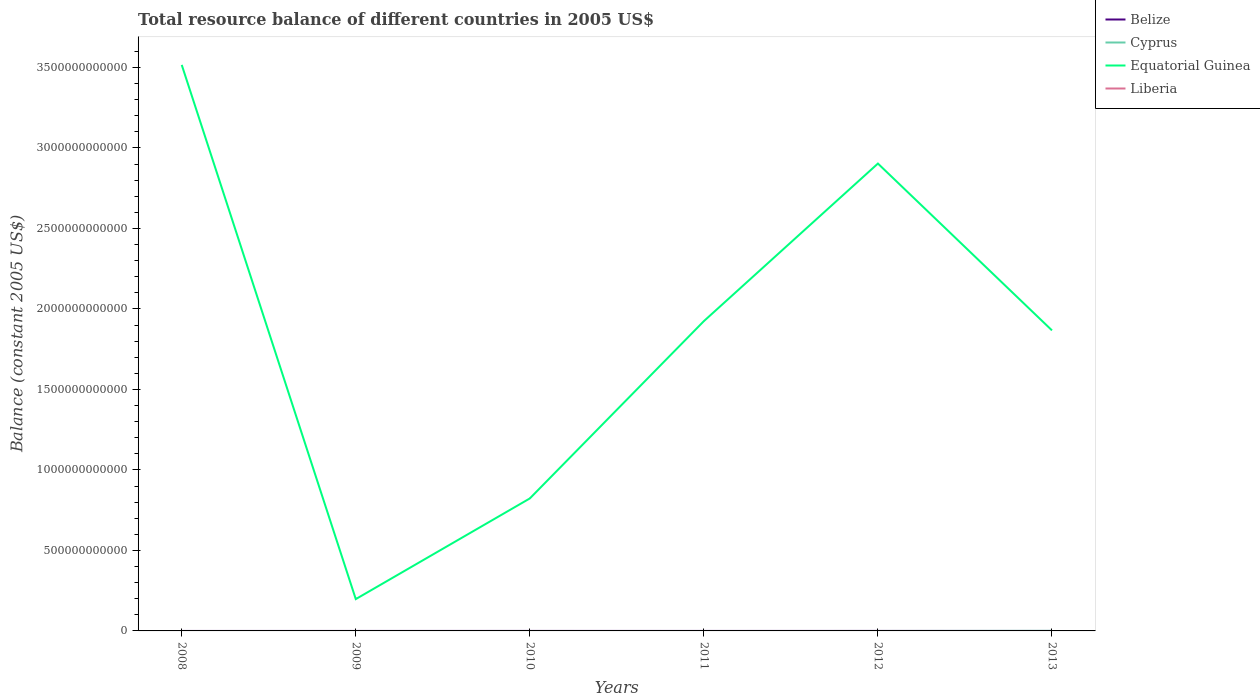How many different coloured lines are there?
Your answer should be very brief. 3. What is the total total resource balance in Equatorial Guinea in the graph?
Your answer should be compact. 1.04e+12. What is the difference between the highest and the second highest total resource balance in Belize?
Give a very brief answer. 2.07e+07. What is the difference between the highest and the lowest total resource balance in Belize?
Keep it short and to the point. 1. Is the total resource balance in Equatorial Guinea strictly greater than the total resource balance in Belize over the years?
Your response must be concise. No. How many years are there in the graph?
Offer a very short reply. 6. What is the difference between two consecutive major ticks on the Y-axis?
Offer a terse response. 5.00e+11. Does the graph contain grids?
Offer a very short reply. No. Where does the legend appear in the graph?
Offer a very short reply. Top right. How are the legend labels stacked?
Make the answer very short. Vertical. What is the title of the graph?
Make the answer very short. Total resource balance of different countries in 2005 US$. What is the label or title of the X-axis?
Your answer should be very brief. Years. What is the label or title of the Y-axis?
Provide a short and direct response. Balance (constant 2005 US$). What is the Balance (constant 2005 US$) in Belize in 2008?
Give a very brief answer. 0. What is the Balance (constant 2005 US$) of Equatorial Guinea in 2008?
Give a very brief answer. 3.52e+12. What is the Balance (constant 2005 US$) in Liberia in 2008?
Your answer should be compact. 0. What is the Balance (constant 2005 US$) in Cyprus in 2009?
Provide a succinct answer. 0. What is the Balance (constant 2005 US$) of Equatorial Guinea in 2009?
Give a very brief answer. 1.98e+11. What is the Balance (constant 2005 US$) of Liberia in 2009?
Your answer should be very brief. 0. What is the Balance (constant 2005 US$) of Belize in 2010?
Offer a very short reply. 2.07e+07. What is the Balance (constant 2005 US$) in Equatorial Guinea in 2010?
Your response must be concise. 8.23e+11. What is the Balance (constant 2005 US$) of Equatorial Guinea in 2011?
Ensure brevity in your answer.  1.92e+12. What is the Balance (constant 2005 US$) in Cyprus in 2012?
Provide a short and direct response. 0. What is the Balance (constant 2005 US$) of Equatorial Guinea in 2012?
Offer a terse response. 2.90e+12. What is the Balance (constant 2005 US$) of Cyprus in 2013?
Offer a very short reply. 4.50e+08. What is the Balance (constant 2005 US$) of Equatorial Guinea in 2013?
Your answer should be compact. 1.87e+12. What is the Balance (constant 2005 US$) of Liberia in 2013?
Your response must be concise. 0. Across all years, what is the maximum Balance (constant 2005 US$) of Belize?
Your response must be concise. 2.07e+07. Across all years, what is the maximum Balance (constant 2005 US$) of Cyprus?
Your answer should be compact. 4.50e+08. Across all years, what is the maximum Balance (constant 2005 US$) of Equatorial Guinea?
Provide a short and direct response. 3.52e+12. Across all years, what is the minimum Balance (constant 2005 US$) of Equatorial Guinea?
Offer a terse response. 1.98e+11. What is the total Balance (constant 2005 US$) of Belize in the graph?
Offer a very short reply. 2.07e+07. What is the total Balance (constant 2005 US$) in Cyprus in the graph?
Your response must be concise. 4.50e+08. What is the total Balance (constant 2005 US$) of Equatorial Guinea in the graph?
Give a very brief answer. 1.12e+13. What is the total Balance (constant 2005 US$) of Liberia in the graph?
Keep it short and to the point. 0. What is the difference between the Balance (constant 2005 US$) in Equatorial Guinea in 2008 and that in 2009?
Provide a short and direct response. 3.32e+12. What is the difference between the Balance (constant 2005 US$) in Equatorial Guinea in 2008 and that in 2010?
Your response must be concise. 2.69e+12. What is the difference between the Balance (constant 2005 US$) of Equatorial Guinea in 2008 and that in 2011?
Provide a short and direct response. 1.59e+12. What is the difference between the Balance (constant 2005 US$) in Equatorial Guinea in 2008 and that in 2012?
Make the answer very short. 6.13e+11. What is the difference between the Balance (constant 2005 US$) in Equatorial Guinea in 2008 and that in 2013?
Your answer should be very brief. 1.65e+12. What is the difference between the Balance (constant 2005 US$) in Equatorial Guinea in 2009 and that in 2010?
Offer a very short reply. -6.25e+11. What is the difference between the Balance (constant 2005 US$) of Equatorial Guinea in 2009 and that in 2011?
Keep it short and to the point. -1.73e+12. What is the difference between the Balance (constant 2005 US$) of Equatorial Guinea in 2009 and that in 2012?
Make the answer very short. -2.71e+12. What is the difference between the Balance (constant 2005 US$) in Equatorial Guinea in 2009 and that in 2013?
Provide a short and direct response. -1.67e+12. What is the difference between the Balance (constant 2005 US$) of Equatorial Guinea in 2010 and that in 2011?
Make the answer very short. -1.10e+12. What is the difference between the Balance (constant 2005 US$) of Equatorial Guinea in 2010 and that in 2012?
Your response must be concise. -2.08e+12. What is the difference between the Balance (constant 2005 US$) of Equatorial Guinea in 2010 and that in 2013?
Keep it short and to the point. -1.04e+12. What is the difference between the Balance (constant 2005 US$) of Equatorial Guinea in 2011 and that in 2012?
Give a very brief answer. -9.79e+11. What is the difference between the Balance (constant 2005 US$) in Equatorial Guinea in 2011 and that in 2013?
Provide a short and direct response. 5.76e+1. What is the difference between the Balance (constant 2005 US$) in Equatorial Guinea in 2012 and that in 2013?
Your response must be concise. 1.04e+12. What is the difference between the Balance (constant 2005 US$) in Belize in 2010 and the Balance (constant 2005 US$) in Equatorial Guinea in 2011?
Offer a terse response. -1.92e+12. What is the difference between the Balance (constant 2005 US$) in Belize in 2010 and the Balance (constant 2005 US$) in Equatorial Guinea in 2012?
Provide a short and direct response. -2.90e+12. What is the difference between the Balance (constant 2005 US$) of Belize in 2010 and the Balance (constant 2005 US$) of Cyprus in 2013?
Ensure brevity in your answer.  -4.30e+08. What is the difference between the Balance (constant 2005 US$) in Belize in 2010 and the Balance (constant 2005 US$) in Equatorial Guinea in 2013?
Give a very brief answer. -1.87e+12. What is the average Balance (constant 2005 US$) of Belize per year?
Provide a succinct answer. 3.45e+06. What is the average Balance (constant 2005 US$) in Cyprus per year?
Your response must be concise. 7.50e+07. What is the average Balance (constant 2005 US$) of Equatorial Guinea per year?
Make the answer very short. 1.87e+12. What is the average Balance (constant 2005 US$) in Liberia per year?
Provide a short and direct response. 0. In the year 2010, what is the difference between the Balance (constant 2005 US$) of Belize and Balance (constant 2005 US$) of Equatorial Guinea?
Make the answer very short. -8.23e+11. In the year 2013, what is the difference between the Balance (constant 2005 US$) in Cyprus and Balance (constant 2005 US$) in Equatorial Guinea?
Your response must be concise. -1.87e+12. What is the ratio of the Balance (constant 2005 US$) in Equatorial Guinea in 2008 to that in 2009?
Offer a very short reply. 17.79. What is the ratio of the Balance (constant 2005 US$) of Equatorial Guinea in 2008 to that in 2010?
Provide a short and direct response. 4.27. What is the ratio of the Balance (constant 2005 US$) of Equatorial Guinea in 2008 to that in 2011?
Give a very brief answer. 1.83. What is the ratio of the Balance (constant 2005 US$) of Equatorial Guinea in 2008 to that in 2012?
Give a very brief answer. 1.21. What is the ratio of the Balance (constant 2005 US$) in Equatorial Guinea in 2008 to that in 2013?
Your response must be concise. 1.88. What is the ratio of the Balance (constant 2005 US$) in Equatorial Guinea in 2009 to that in 2010?
Your answer should be compact. 0.24. What is the ratio of the Balance (constant 2005 US$) in Equatorial Guinea in 2009 to that in 2011?
Give a very brief answer. 0.1. What is the ratio of the Balance (constant 2005 US$) in Equatorial Guinea in 2009 to that in 2012?
Keep it short and to the point. 0.07. What is the ratio of the Balance (constant 2005 US$) in Equatorial Guinea in 2009 to that in 2013?
Ensure brevity in your answer.  0.11. What is the ratio of the Balance (constant 2005 US$) of Equatorial Guinea in 2010 to that in 2011?
Make the answer very short. 0.43. What is the ratio of the Balance (constant 2005 US$) of Equatorial Guinea in 2010 to that in 2012?
Give a very brief answer. 0.28. What is the ratio of the Balance (constant 2005 US$) in Equatorial Guinea in 2010 to that in 2013?
Keep it short and to the point. 0.44. What is the ratio of the Balance (constant 2005 US$) of Equatorial Guinea in 2011 to that in 2012?
Offer a very short reply. 0.66. What is the ratio of the Balance (constant 2005 US$) of Equatorial Guinea in 2011 to that in 2013?
Offer a terse response. 1.03. What is the ratio of the Balance (constant 2005 US$) in Equatorial Guinea in 2012 to that in 2013?
Offer a terse response. 1.56. What is the difference between the highest and the second highest Balance (constant 2005 US$) in Equatorial Guinea?
Your answer should be very brief. 6.13e+11. What is the difference between the highest and the lowest Balance (constant 2005 US$) in Belize?
Offer a very short reply. 2.07e+07. What is the difference between the highest and the lowest Balance (constant 2005 US$) in Cyprus?
Give a very brief answer. 4.50e+08. What is the difference between the highest and the lowest Balance (constant 2005 US$) of Equatorial Guinea?
Make the answer very short. 3.32e+12. 